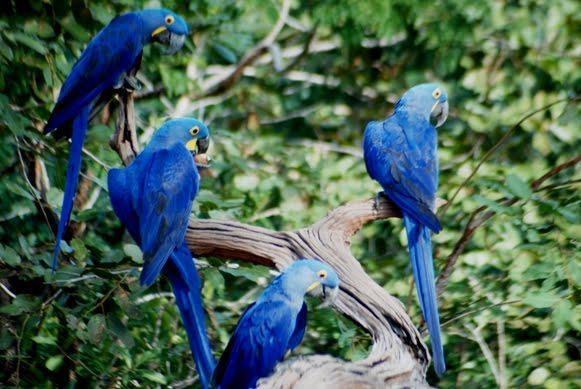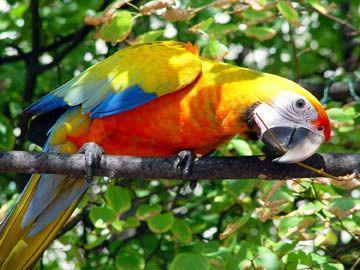The first image is the image on the left, the second image is the image on the right. Given the left and right images, does the statement "The right image features a blue-and-yellow parrot only, and the left image includes at least one red-headed parrot." hold true? Answer yes or no. No. The first image is the image on the left, the second image is the image on the right. Considering the images on both sides, is "In one image there are four blue birds perched on a branch." valid? Answer yes or no. Yes. 